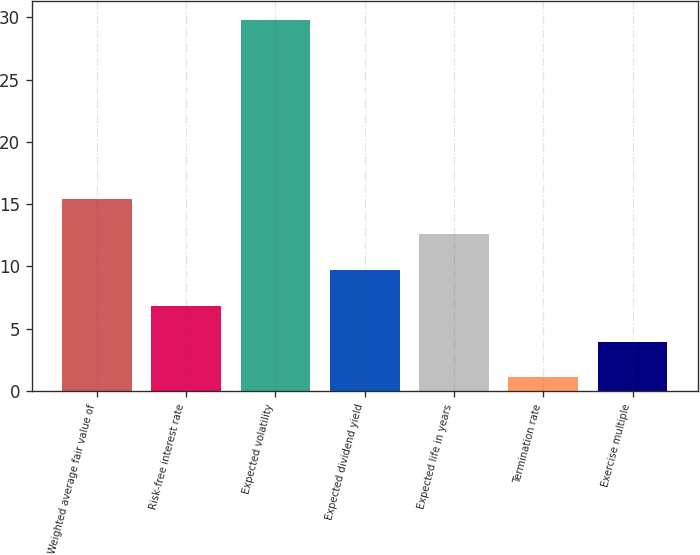<chart> <loc_0><loc_0><loc_500><loc_500><bar_chart><fcel>Weighted average fair value of<fcel>Risk-free interest rate<fcel>Expected volatility<fcel>Expected dividend yield<fcel>Expected life in years<fcel>Termination rate<fcel>Exercise multiple<nl><fcel>15.44<fcel>6.83<fcel>29.8<fcel>9.7<fcel>12.57<fcel>1.09<fcel>3.96<nl></chart> 